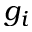<formula> <loc_0><loc_0><loc_500><loc_500>g _ { i }</formula> 